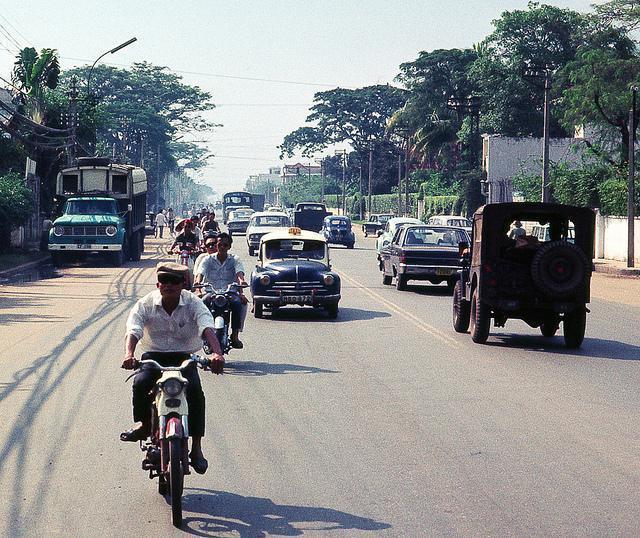What are is the image from?
Make your selection and explain in format: 'Answer: answer
Rationale: rationale.'
Options: Forest, underground, city, sky. Answer: city.
Rationale: The structure of the road and the buildings in the background and the volume of cars visible is all consistent with answer a. 